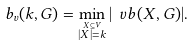<formula> <loc_0><loc_0><loc_500><loc_500>b _ { v } ( k , G ) = \min _ { \stackrel { X \subseteq V } { | X | = k } } | \ v b ( X , G ) | .</formula> 